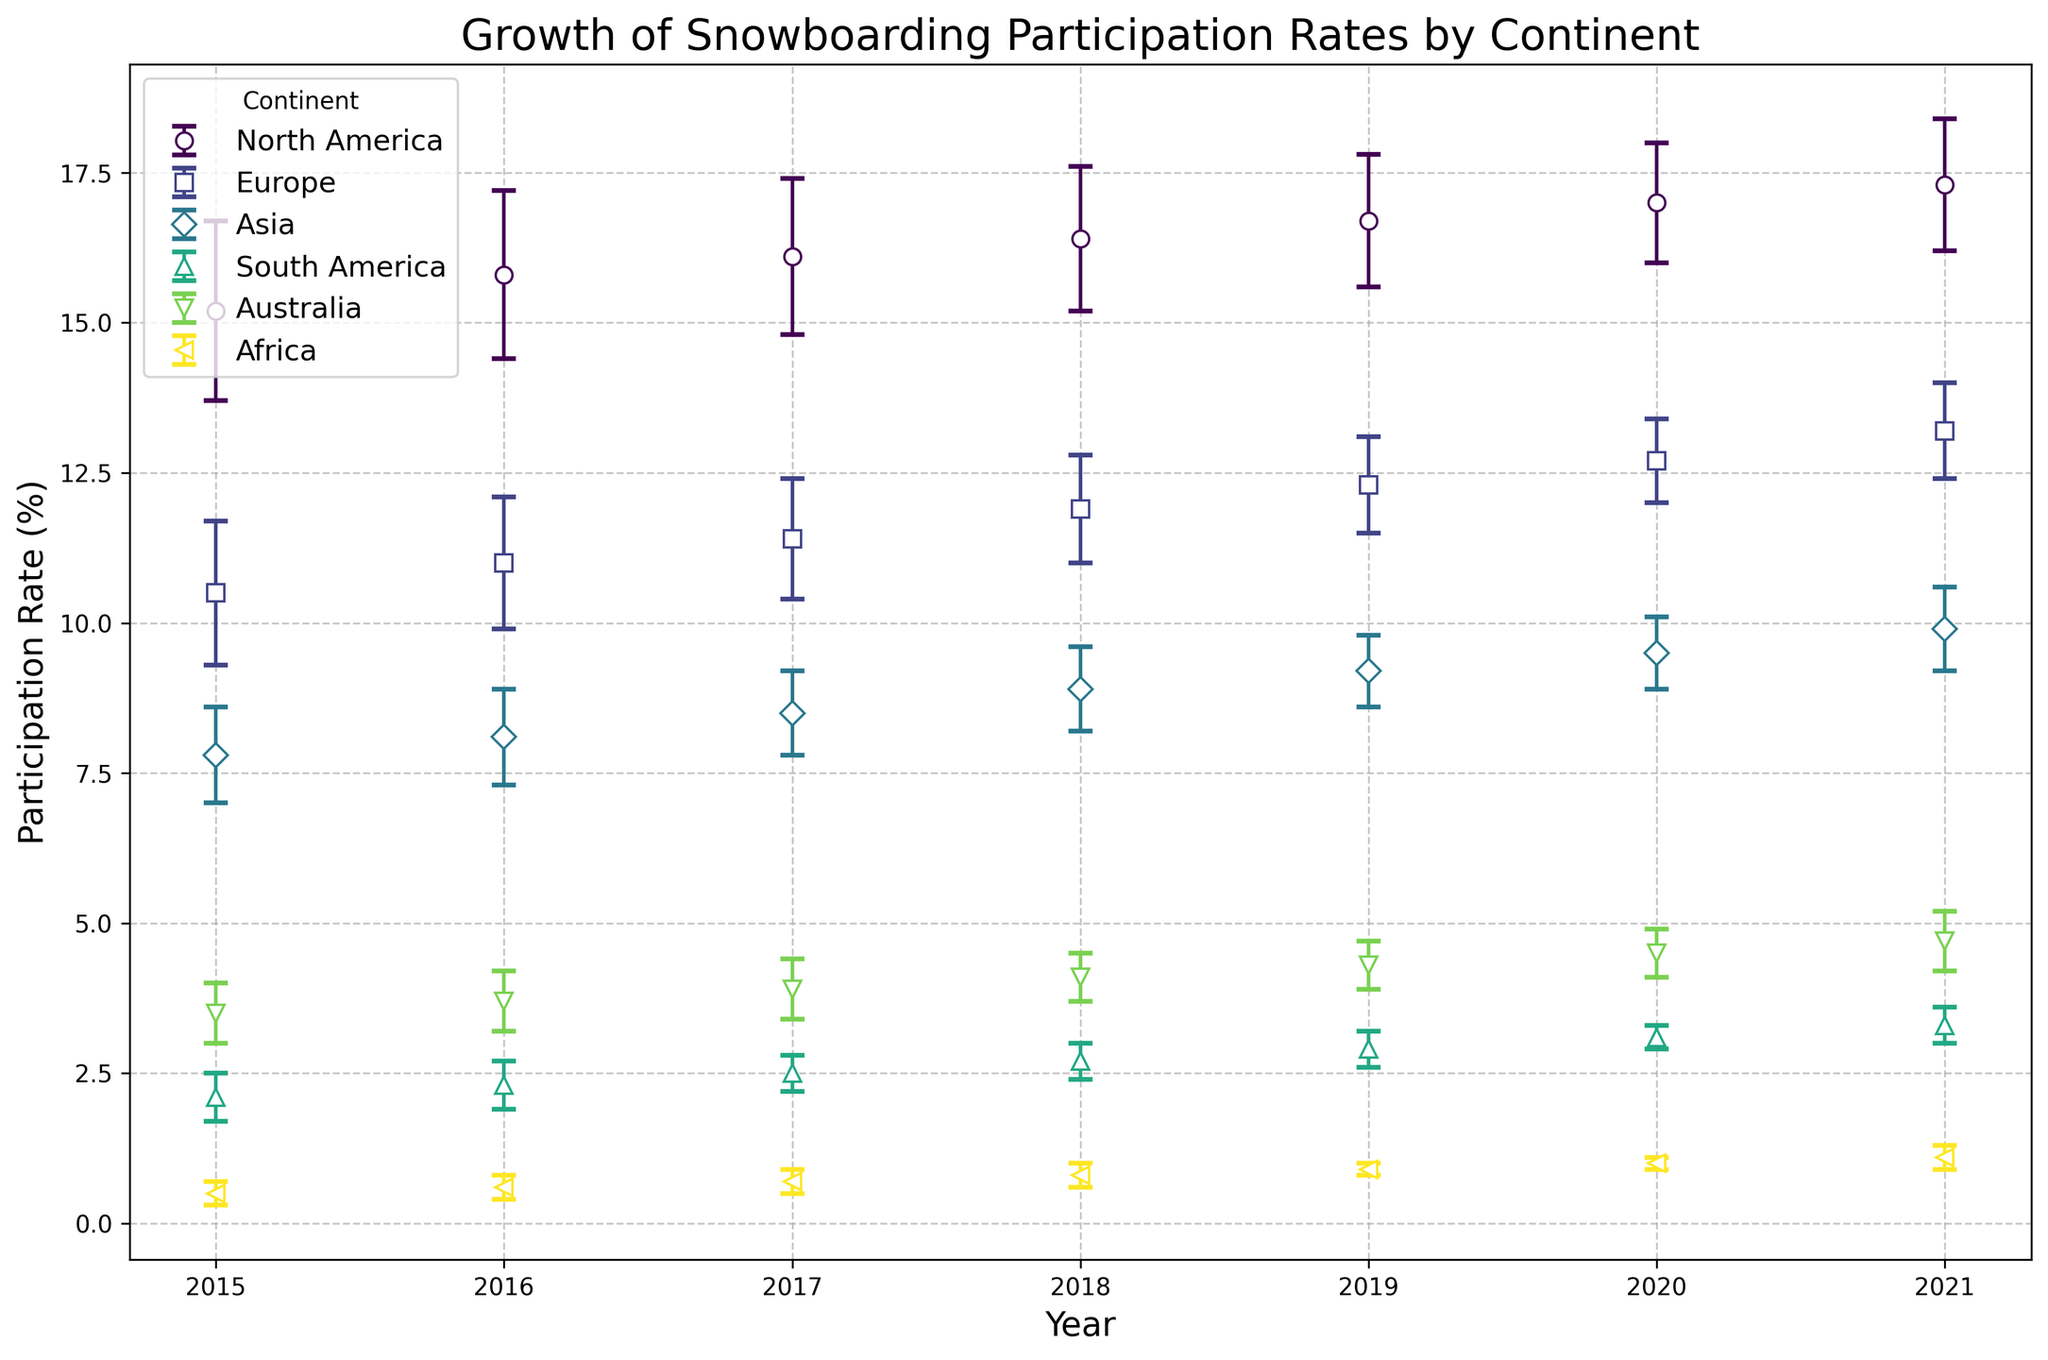What was the participation rate in Africa in 2018? Look for the data point for Africa in 2018 on the x-axis and read the corresponding y-axis value for participation rate.
Answer: 0.8% Which continent had the highest participation rate in 2021? Identify the participation rates for 2021 across all continents and compare them to determine the highest.
Answer: North America Between 2015 and 2021, which continent showed the largest increase in participation rate? Calculate the increase in participation rate for each continent from 2015 to 2021 and compare the differences.
Answer: North America In which year did Europe have its fastest increase in participation rate? Look at the year-over-year changes in participation rate for Europe and identify the year with the largest increase.
Answer: 2017 to 2018 Compare the participation rates of Asia and South America in 2019. Which one was higher? Locate the participation rates for Asia and South America in 2019 and compare the values.
Answer: Asia What is the uncertainty range for North America in 2020? Identify the data point for North America in 2020 and read the corresponding uncertainty value.
Answer: ±1.0% By how much did the participation rate in Africa increase between 2015 and 2020? Subtract the participation rate of Africa in 2015 from that in 2020 to find the increase.
Answer: 0.5% Which continent showed the smallest increase in participation rate from 2015 to 2021? Calculate the increase in participation rate for each continent from 2015 to 2021 and identify the smallest increase.
Answer: Africa What was the participation rate difference between Europe and Australia in 2017? Subtract the participation rate of Australia from that of Europe in 2017.
Answer: 7.5% Which continent had the most stable growth of participation rate, based on the uncertainty values? Compare the uncertainty values over the years for each continent and identify the one with the smallest and most consistent uncertainties.
Answer: Africa 